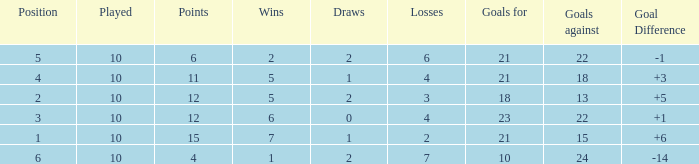Can you tell me the total number of Wins that has the Draws larger than 0, and the Points of 11? 1.0. 